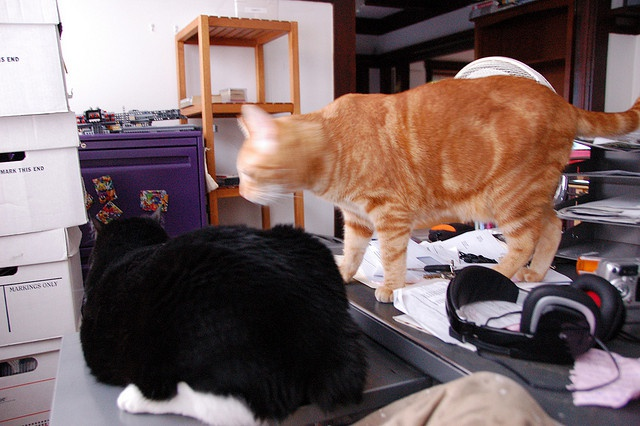Describe the objects in this image and their specific colors. I can see cat in lavender, black, lightgray, darkgray, and gray tones, cat in white, brown, salmon, and tan tones, book in lavender and darkgray tones, book in lavender, darkgray, gray, and lightgray tones, and book in lavender, violet, black, and brown tones in this image. 